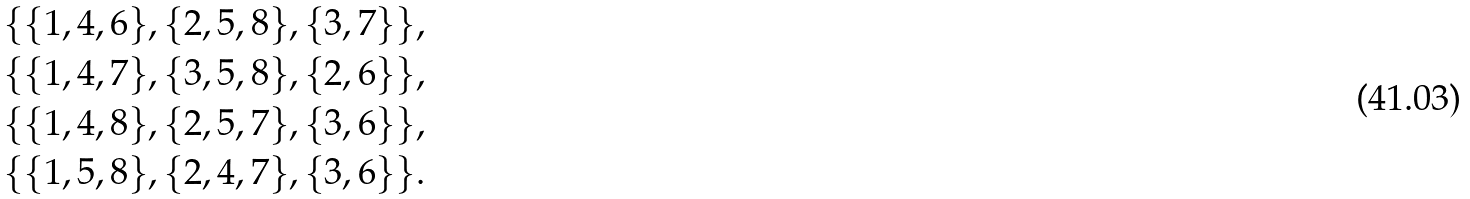Convert formula to latex. <formula><loc_0><loc_0><loc_500><loc_500>& \{ \{ 1 , 4 , 6 \} , \{ 2 , 5 , 8 \} , \{ 3 , 7 \} \} , \\ & \{ \{ 1 , 4 , 7 \} , \{ 3 , 5 , 8 \} , \{ 2 , 6 \} \} , \\ & \{ \{ 1 , 4 , 8 \} , \{ 2 , 5 , 7 \} , \{ 3 , 6 \} \} , \\ & \{ \{ 1 , 5 , 8 \} , \{ 2 , 4 , 7 \} , \{ 3 , 6 \} \} .</formula> 